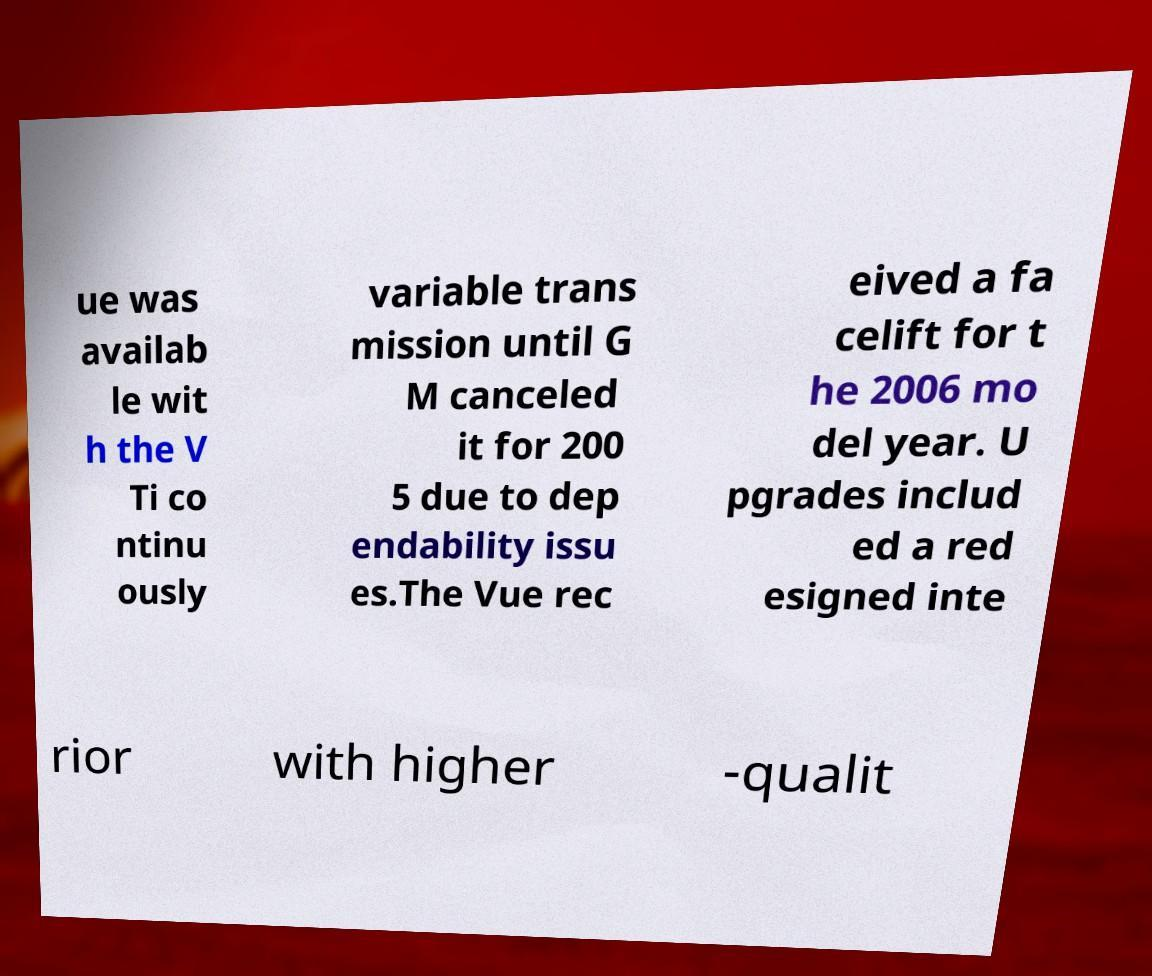For documentation purposes, I need the text within this image transcribed. Could you provide that? ue was availab le wit h the V Ti co ntinu ously variable trans mission until G M canceled it for 200 5 due to dep endability issu es.The Vue rec eived a fa celift for t he 2006 mo del year. U pgrades includ ed a red esigned inte rior with higher -qualit 